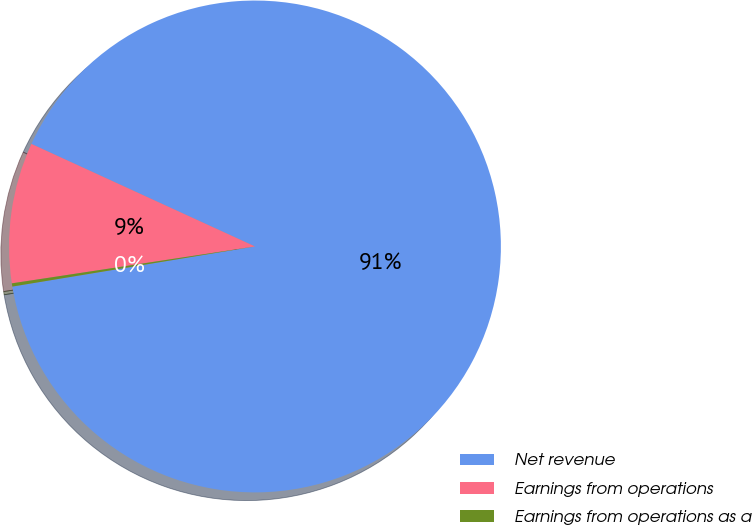Convert chart to OTSL. <chart><loc_0><loc_0><loc_500><loc_500><pie_chart><fcel>Net revenue<fcel>Earnings from operations<fcel>Earnings from operations as a<nl><fcel>90.54%<fcel>9.24%<fcel>0.21%<nl></chart> 